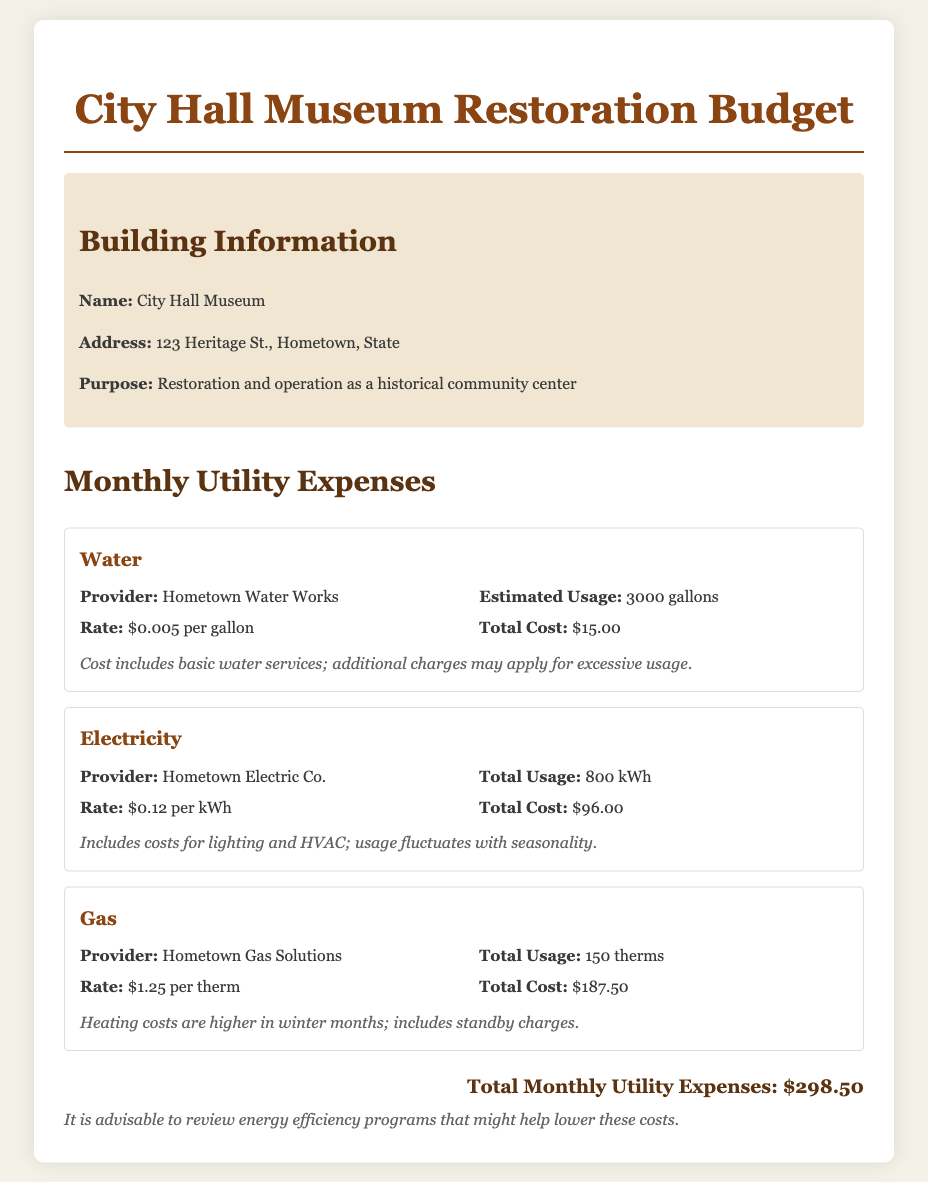What is the total water cost? The total water cost is listed under the water expense section as $15.00.
Answer: $15.00 Who is the electricity provider? The electricity provider is specified in the electricity section of the document as Hometown Electric Co.
Answer: Hometown Electric Co What is the total gas usage? The total gas usage is provided in the gas expense section as 150 therms.
Answer: 150 therms What is the rate per kWh for electricity? The rate per kWh is mentioned in the electricity section as $0.12 per kWh.
Answer: $0.12 per kWh How much is the total monthly utility expense? The total monthly utility expense is calculated and stated as $298.50.
Answer: $298.50 What additional charges may apply for water? Additional charges may apply for excessive usage, as noted in the water expense section.
Answer: Excessive usage What is the estimated usage of water? The estimated usage of water is indicated in the water expense section as 3000 gallons.
Answer: 3000 gallons What type of costs are included in the electricity charges? The costs included in the electricity charges are for lighting and HVAC, as mentioned in the electricity section.
Answer: Lighting and HVAC What pricing strategy is noted for the gas expense? The pricing strategy noted for the gas expense indicates that heating costs are higher in winter months.
Answer: Higher in winter months 